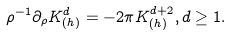Convert formula to latex. <formula><loc_0><loc_0><loc_500><loc_500>\rho ^ { - 1 } \partial _ { \rho } K ^ { d } _ { ( h ) } = - 2 \pi K ^ { d + 2 } _ { ( h ) } , d \geq 1 .</formula> 